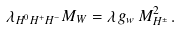<formula> <loc_0><loc_0><loc_500><loc_500>\lambda _ { H ^ { 0 } H ^ { + } H ^ { - } } M _ { W } = \lambda \, g _ { w } \, M _ { H ^ { \pm } } ^ { 2 } \, .</formula> 